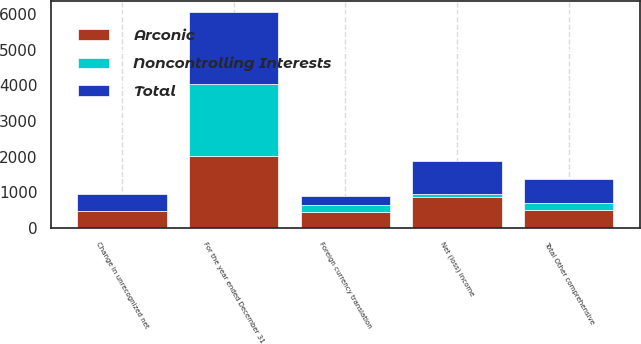<chart> <loc_0><loc_0><loc_500><loc_500><stacked_bar_chart><ecel><fcel>For the year ended December 31<fcel>Net (loss) income<fcel>Change in unrecognized net<fcel>Foreign currency translation<fcel>Total Other comprehensive<nl><fcel>Total<fcel>2016<fcel>941<fcel>479<fcel>268<fcel>691<nl><fcel>Noncontrolling Interests<fcel>2016<fcel>63<fcel>3<fcel>182<fcel>184<nl><fcel>Arconic<fcel>2016<fcel>878<fcel>482<fcel>450<fcel>507<nl></chart> 